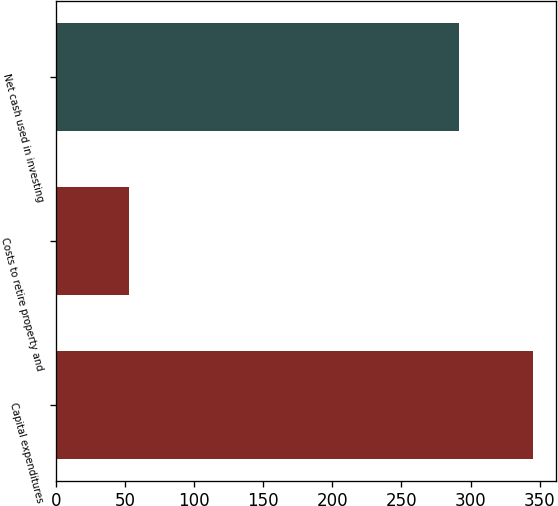Convert chart to OTSL. <chart><loc_0><loc_0><loc_500><loc_500><bar_chart><fcel>Capital expenditures<fcel>Costs to retire property and<fcel>Net cash used in investing<nl><fcel>345<fcel>53<fcel>292<nl></chart> 